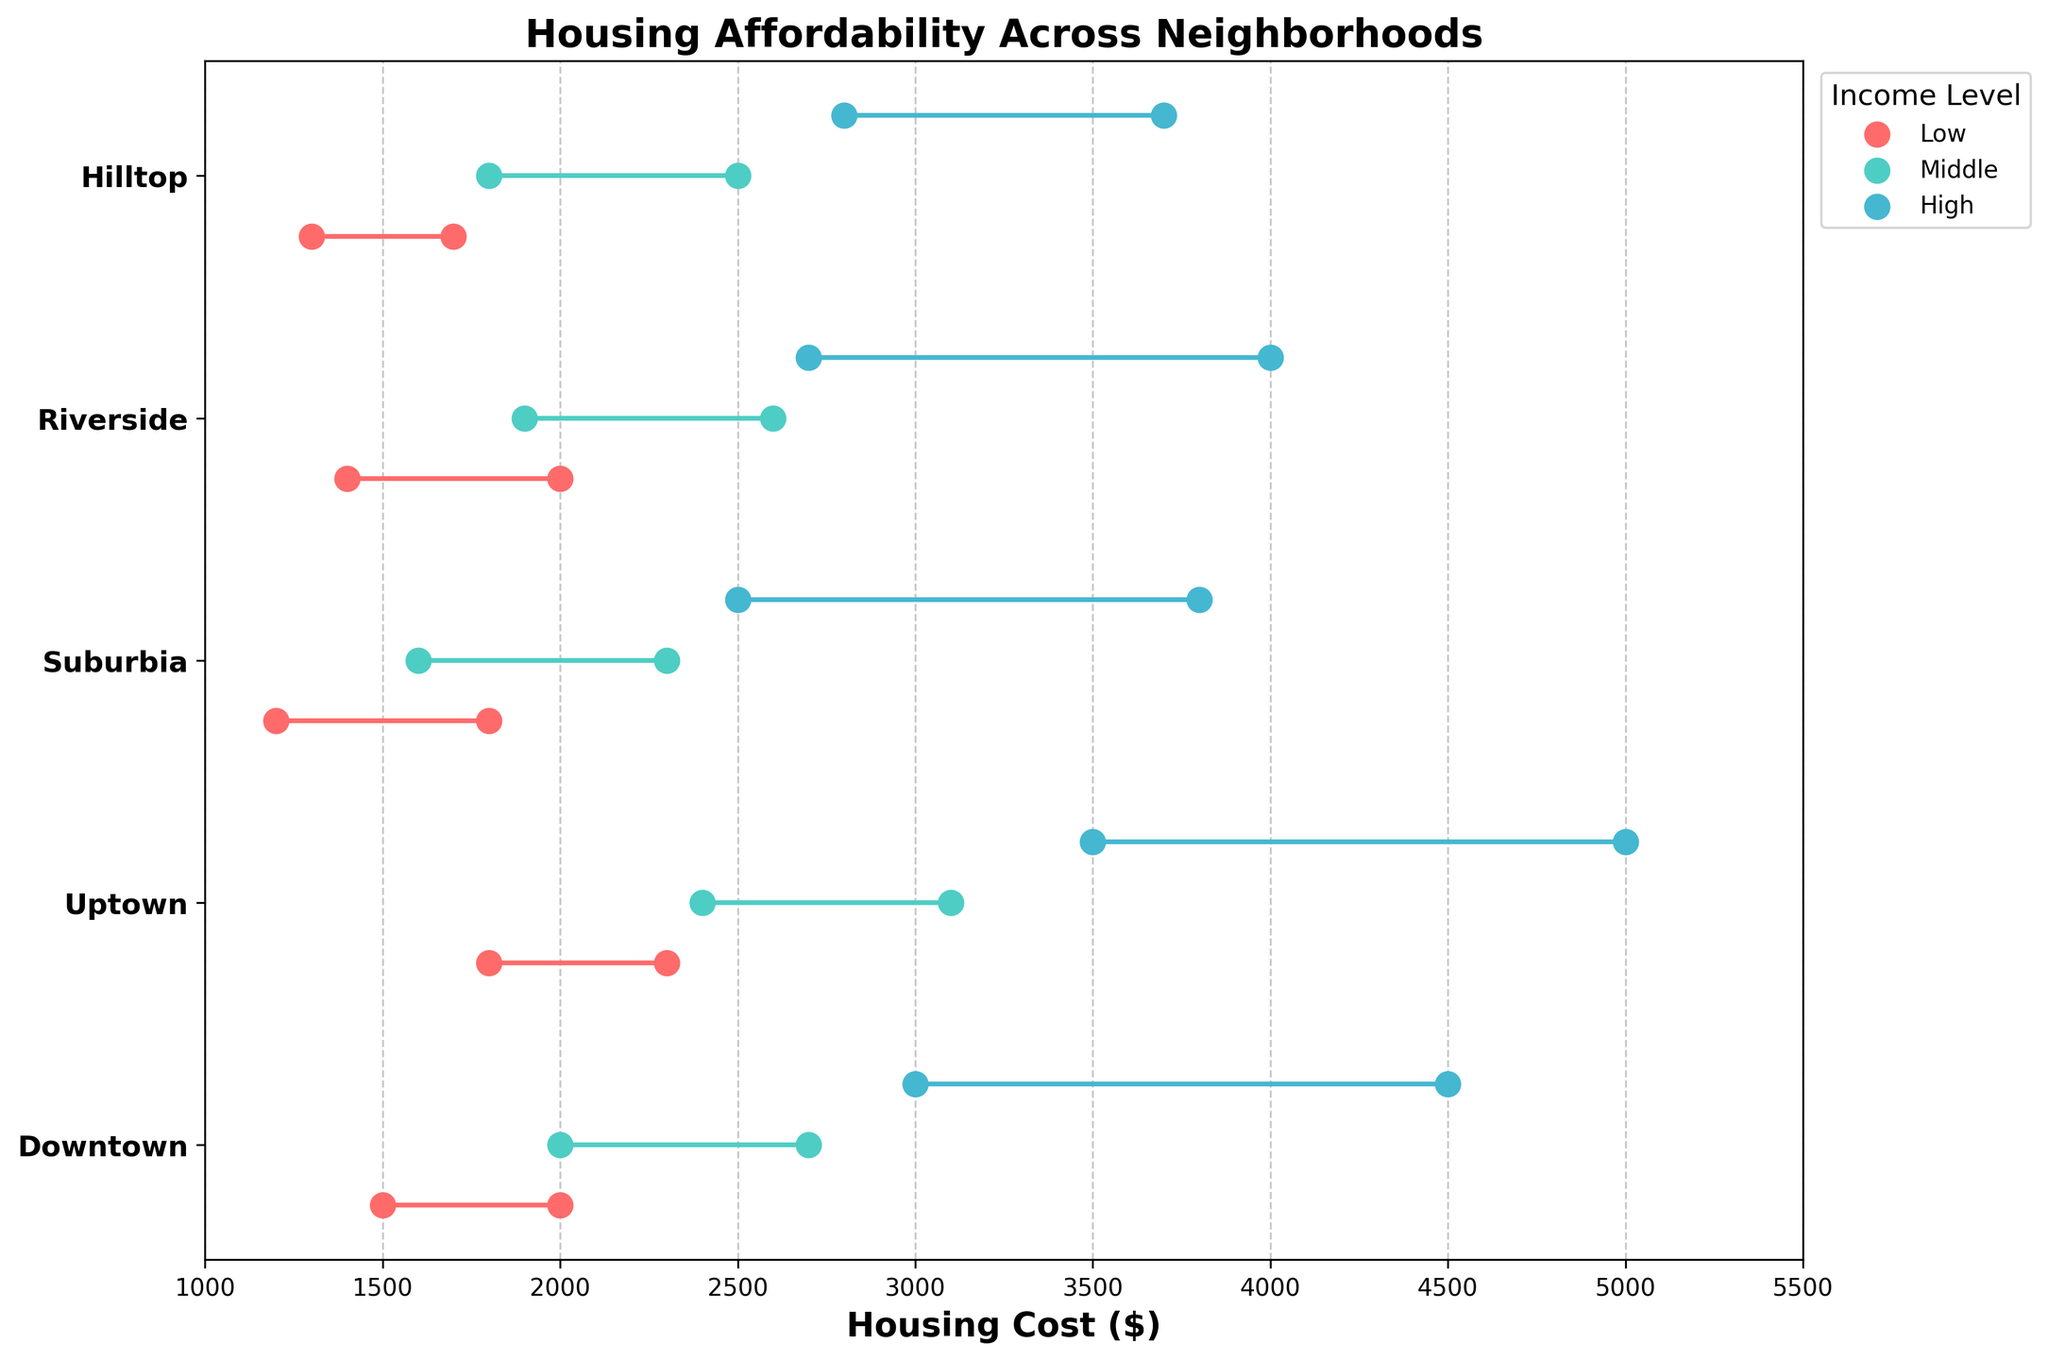What is the title of the plot? The title is written at the top of the plot in a larger font size and gives an overview of what the plot is about.
Answer: Housing Affordability Across Neighborhoods Which neighborhood has the highest housing cost for the high median income level? Identify the dots representing the high median income level across different neighborhoods and find the highest value. The highest dot for high income is in Uptown at $5000.
Answer: Uptown Which neighborhood shows the lowest housing cost for low median income levels? Look at the range dots associated with the low median income level in each neighborhood. The lowest housing cost is in Suburbia at $1200.
Answer: Suburbia What is the range of housing costs for middle median income levels in the Riverside neighborhood? Find the range dots for middle income in Riverside and identify the lowest and highest values. Riverside's range for middle income is $1900 to $2600.
Answer: $1900-$2600 How do the housing costs for high median income levels in Hilltop compare to those in Downtown? Compare the upper and lower bound dots for high income levels in both neighborhoods. Hilltop's range is $2800 to $3700, while Downtown's range is $3000 to $4500.
Answer: Downtown is higher What is the average highest housing cost across all neighborhoods for low median income levels? Sum up the highest housing costs for low income across all neighborhoods and divide by the number of neighborhoods (5): ($2000 + $2300 + $1800 + $2000 + $1700)/5.
Answer: $1960 Which has the greater difference between the highest and lowest housing costs for middle income levels, Uptown or Suburbia? Calculate the range (high-low) for both, and compare: Uptown ($3100-$2400 = $700) and Suburbia ($2300-$1600 = $700). Both are the same.
Answer: They are equal Which income level shows the widest range of housing costs in Downtown? Compare the ranges for all income levels: Low ($2000-$1500 = $500), Middle ($2700-$2000 = $700), High ($4500-$3000 = $1500). The high income level has the widest range at 1500.
Answer: High In which neighborhood does the low median income level have a higher housing cost range than the high median income level in another neighborhood? Compare the ranges of low and high income across neighborhoods. Low in Uptown ($2300-$1800 = $500) is higher than High in Hilltop ($3700-$2800 = $900), which is not. So, there is no such case.
Answer: None Which neighborhoods exhibit overlapping ranges for middle and high median income levels? Identify the overlap in the range dots for middle and high income levels within each neighborhood. Middle (1900-2600) and High (2700-4000) in Riverside overlap, whereas in other neighborhoods, they do not overlap.
Answer: Riverside 